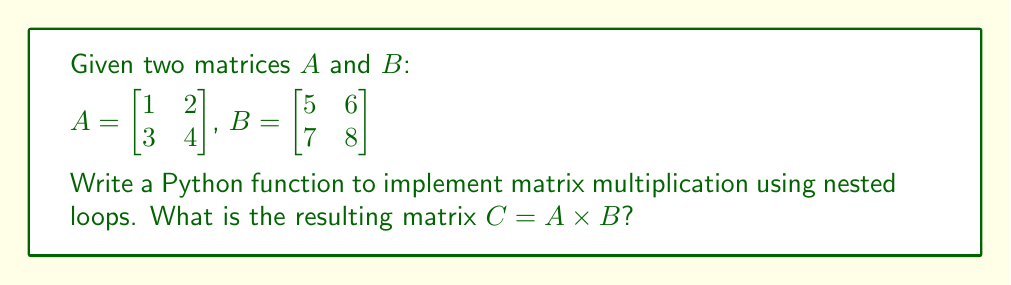Teach me how to tackle this problem. To implement matrix multiplication using nested loops in Python, we can follow these steps:

1. Define the function:
```python
def matrix_multiply(A, B):
    rows_A = len(A)
    cols_A = len(A[0])
    cols_B = len(B[0])
    C = [[0 for _ in range(cols_B)] for _ in range(rows_A)]
    
    for i in range(rows_A):
        for j in range(cols_B):
            for k in range(cols_A):
                C[i][j] += A[i][k] * B[k][j]
    
    return C
```

2. Calculate $C = A \times B$:
   - The resulting matrix $C$ will have the same number of rows as $A$ and the same number of columns as $B$.
   - Each element $c_{ij}$ of $C$ is the dot product of the $i$-th row of $A$ and the $j$-th column of $B$.

3. Perform the multiplication:
   $$C_{11} = (1 \times 5) + (2 \times 7) = 5 + 14 = 19$$
   $$C_{12} = (1 \times 6) + (2 \times 8) = 6 + 16 = 22$$
   $$C_{21} = (3 \times 5) + (4 \times 7) = 15 + 28 = 43$$
   $$C_{22} = (3 \times 6) + (4 \times 8) = 18 + 32 = 50$$

4. The resulting matrix $C$ is:
   $$C = \begin{bmatrix}
   19 & 22 \\
   43 & 50
   \end{bmatrix}$$
Answer: $C = \begin{bmatrix}
19 & 22 \\
43 & 50
\end{bmatrix}$ 